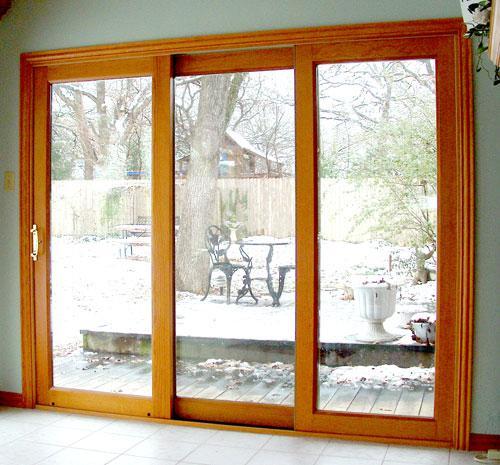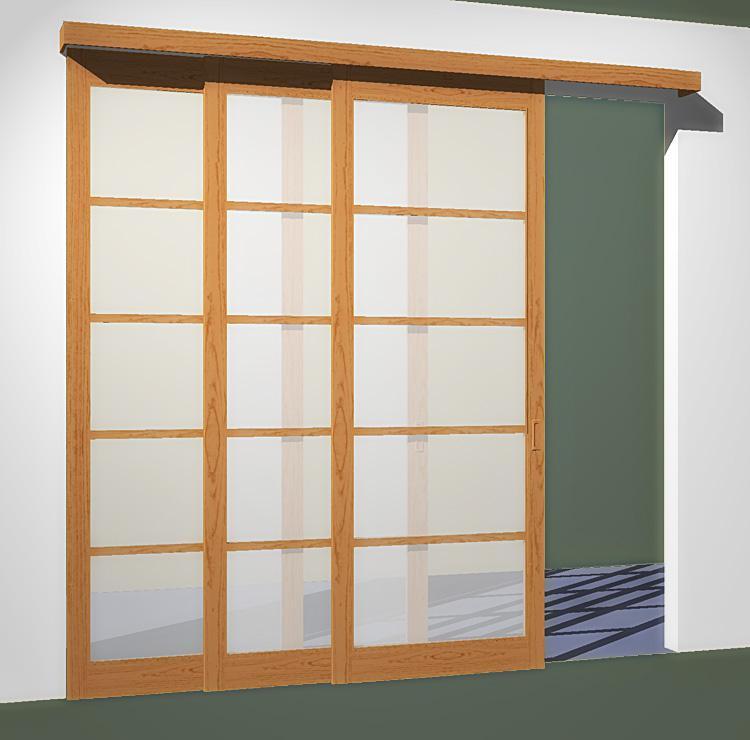The first image is the image on the left, the second image is the image on the right. Assess this claim about the two images: "An image shows a nearly square sliding door unit, with one door partly open, less than a quarter of the way.". Correct or not? Answer yes or no. Yes. The first image is the image on the left, the second image is the image on the right. Considering the images on both sides, is "There is a flower vase on top of a table near a sliding door." valid? Answer yes or no. No. 